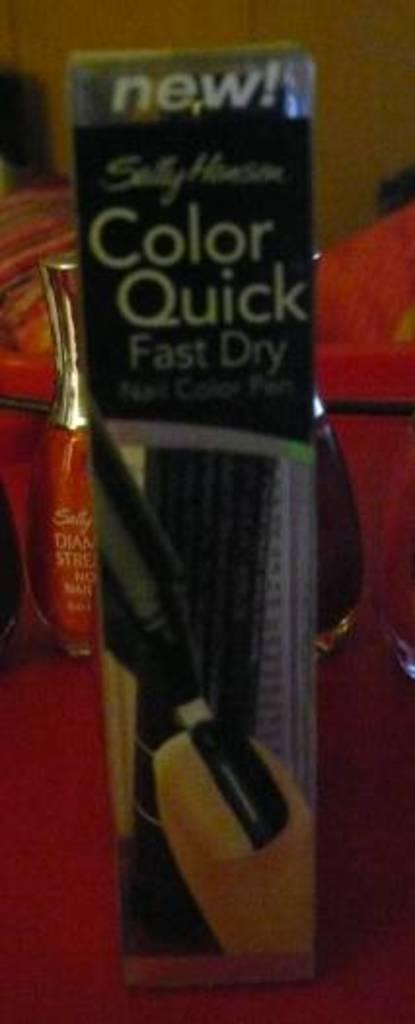What type of dry does this product have?
Provide a succinct answer. Fast. What is the word on the top?
Your answer should be compact. New. 